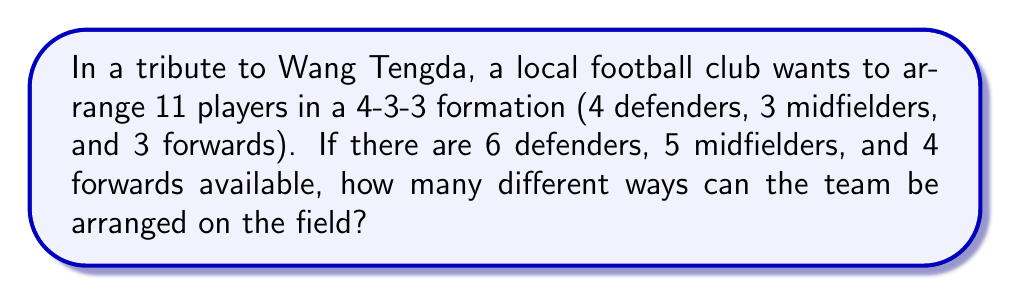Can you solve this math problem? Let's break this down step-by-step:

1) First, we need to choose the players for each position:
   - Choose 4 defenders from 6 available: $\binom{6}{4}$
   - Choose 3 midfielders from 5 available: $\binom{5}{3}$
   - Choose 3 forwards from 4 available: $\binom{4}{3}$

2) The number of ways to choose players for each position is:
   $$\binom{6}{4} \times \binom{5}{3} \times \binom{4}{3}$$

3) Calculate each combination:
   $$\binom{6}{4} = \frac{6!}{4!(6-4)!} = \frac{6 \times 5}{2 \times 1} = 15$$
   $$\binom{5}{3} = \frac{5!}{3!(5-3)!} = \frac{5 \times 4}{2 \times 1} = 10$$
   $$\binom{4}{3} = \frac{4!}{3!(4-3)!} = 4$$

4) Multiply these results:
   $$15 \times 10 \times 4 = 600$$

5) However, this only accounts for selecting the players. We also need to consider the arrangements within each position group.

6) The number of ways to arrange:
   - 4 defenders: $4!$
   - 3 midfielders: $3!$
   - 3 forwards: $3!$

7) Therefore, the total number of arrangements is:
   $$(15 \times 10 \times 4) \times (4! \times 3! \times 3!)$$

8) Calculate:
   $$600 \times (24 \times 6 \times 6) = 600 \times 864 = 518,400$$
Answer: 518,400 